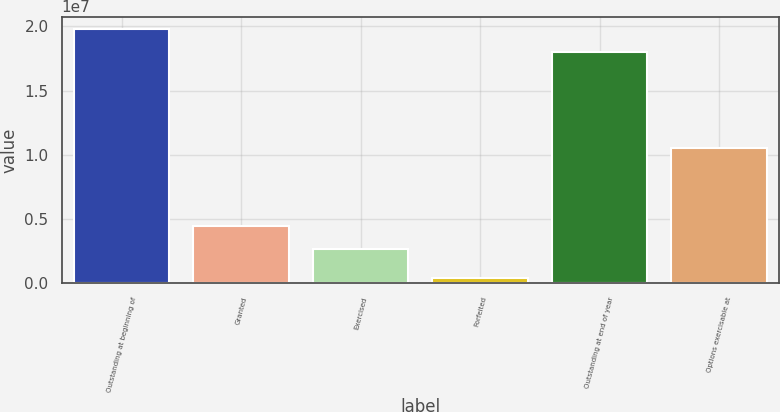<chart> <loc_0><loc_0><loc_500><loc_500><bar_chart><fcel>Outstanding at beginning of<fcel>Granted<fcel>Exercised<fcel>Forfeited<fcel>Outstanding at end of year<fcel>Options exercisable at<nl><fcel>1.97786e+07<fcel>4.42837e+06<fcel>2.64686e+06<fcel>415297<fcel>1.79971e+07<fcel>1.05071e+07<nl></chart> 